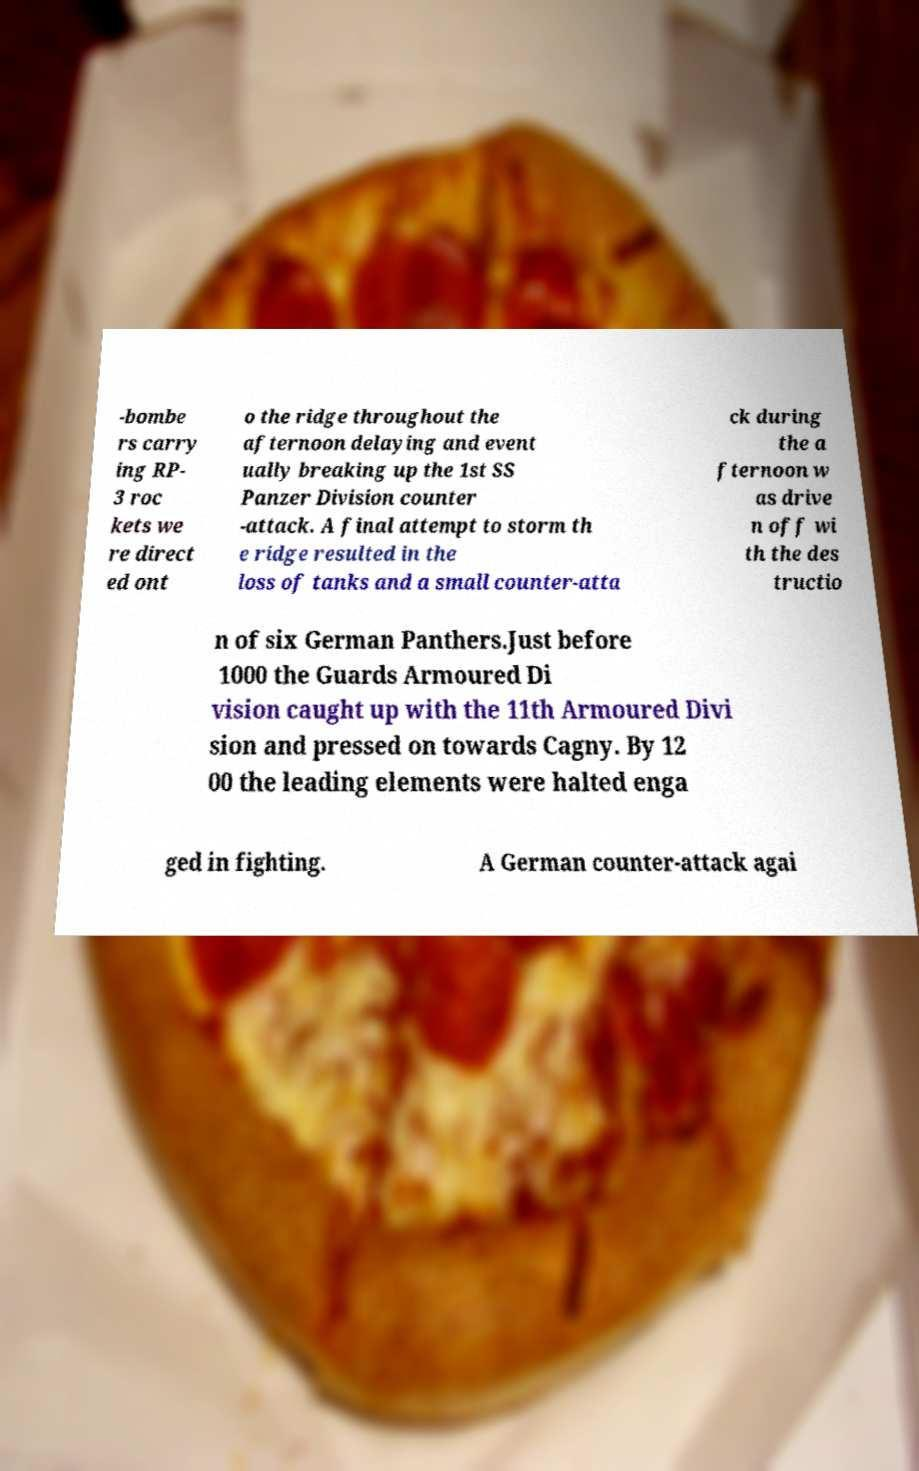Could you extract and type out the text from this image? -bombe rs carry ing RP- 3 roc kets we re direct ed ont o the ridge throughout the afternoon delaying and event ually breaking up the 1st SS Panzer Division counter -attack. A final attempt to storm th e ridge resulted in the loss of tanks and a small counter-atta ck during the a fternoon w as drive n off wi th the des tructio n of six German Panthers.Just before 1000 the Guards Armoured Di vision caught up with the 11th Armoured Divi sion and pressed on towards Cagny. By 12 00 the leading elements were halted enga ged in fighting. A German counter-attack agai 